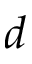<formula> <loc_0><loc_0><loc_500><loc_500>d</formula> 